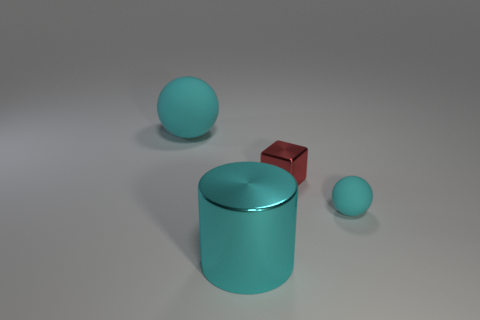Add 2 cyan rubber spheres. How many objects exist? 6 Subtract all blocks. How many objects are left? 3 Add 4 small shiny cubes. How many small shiny cubes exist? 5 Subtract 1 red blocks. How many objects are left? 3 Subtract all large cyan objects. Subtract all big cyan shiny things. How many objects are left? 1 Add 1 small cyan rubber things. How many small cyan rubber things are left? 2 